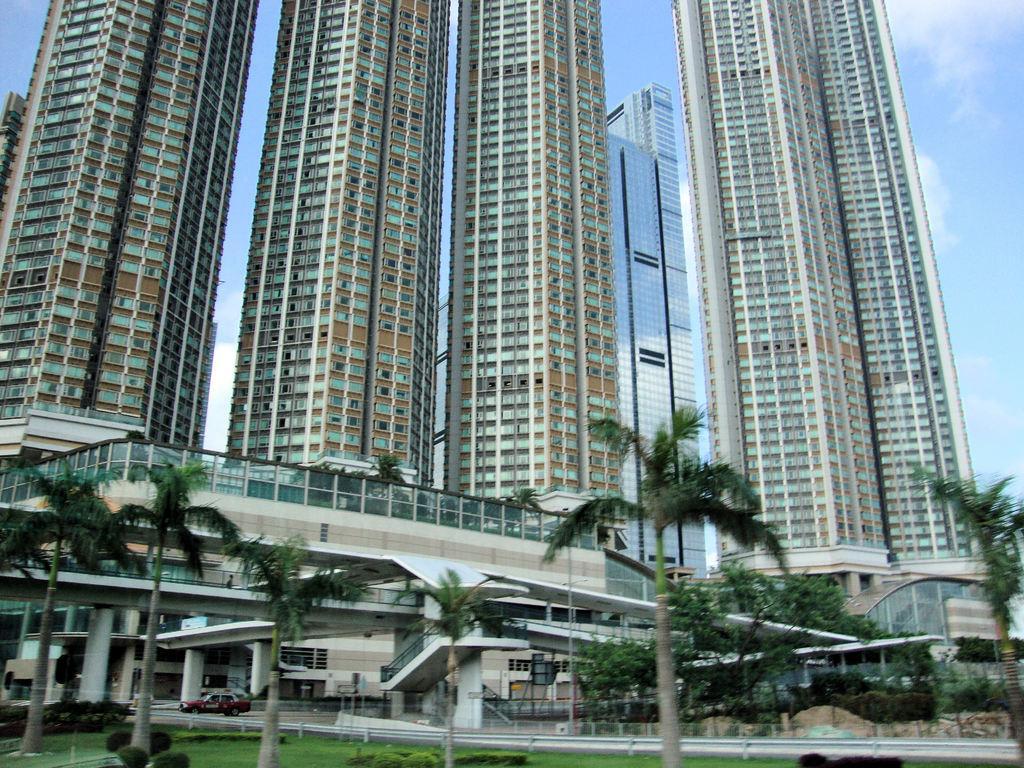How would you summarize this image in a sentence or two? There are trees, stairs and buildings. 